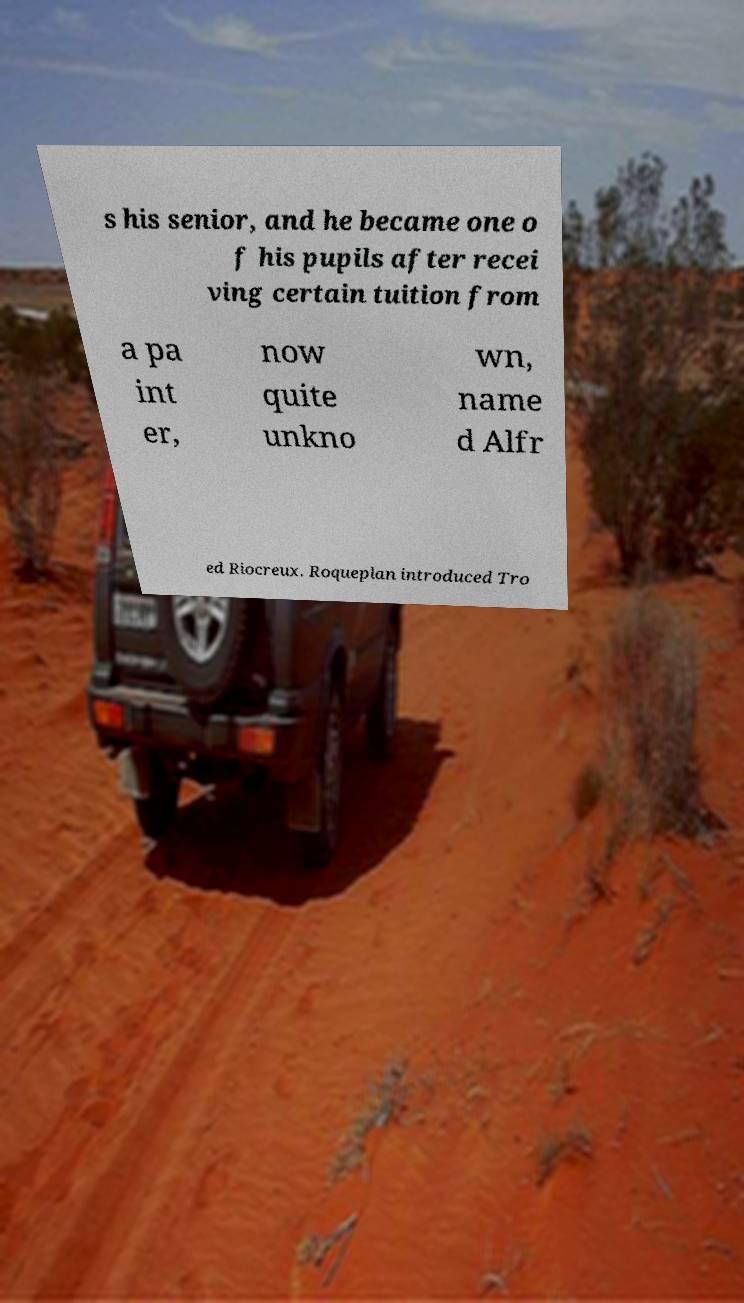Please identify and transcribe the text found in this image. s his senior, and he became one o f his pupils after recei ving certain tuition from a pa int er, now quite unkno wn, name d Alfr ed Riocreux. Roqueplan introduced Tro 